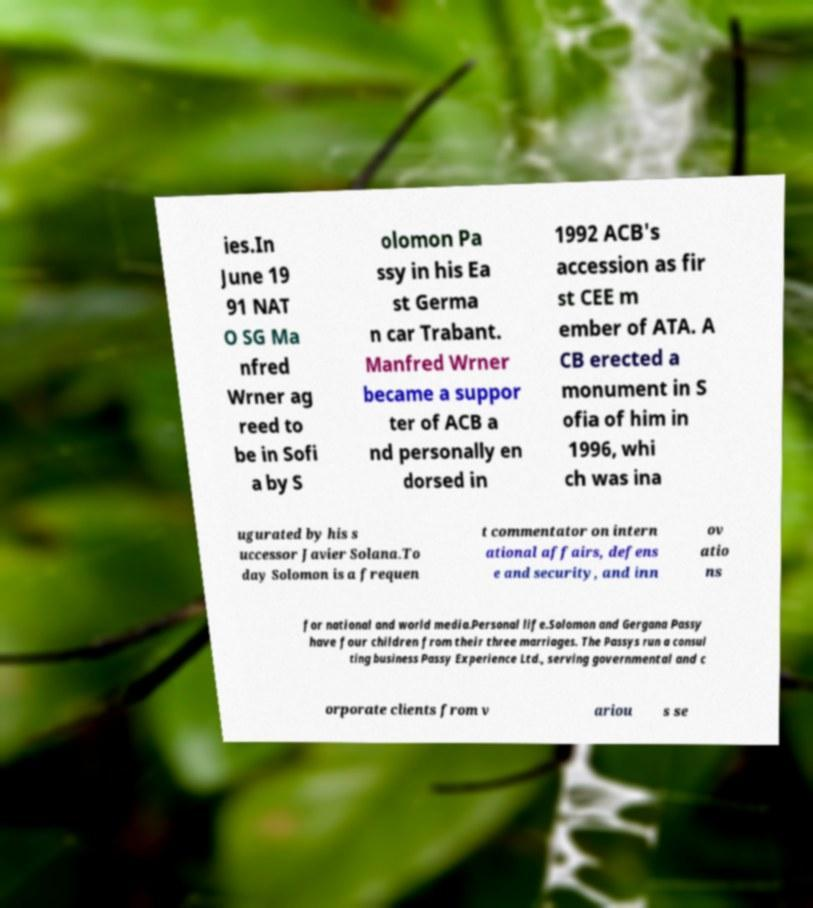Can you read and provide the text displayed in the image?This photo seems to have some interesting text. Can you extract and type it out for me? ies.In June 19 91 NAT O SG Ma nfred Wrner ag reed to be in Sofi a by S olomon Pa ssy in his Ea st Germa n car Trabant. Manfred Wrner became a suppor ter of ACB a nd personally en dorsed in 1992 ACB's accession as fir st CEE m ember of ATA. A CB erected a monument in S ofia of him in 1996, whi ch was ina ugurated by his s uccessor Javier Solana.To day Solomon is a frequen t commentator on intern ational affairs, defens e and security, and inn ov atio ns for national and world media.Personal life.Solomon and Gergana Passy have four children from their three marriages. The Passys run a consul ting business Passy Experience Ltd., serving governmental and c orporate clients from v ariou s se 